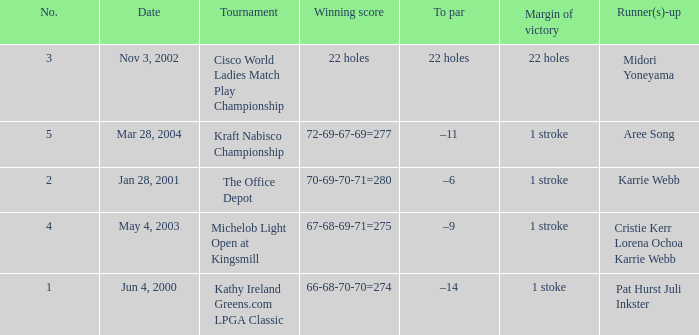What date were the runner ups pat hurst juli inkster? Jun 4, 2000. 